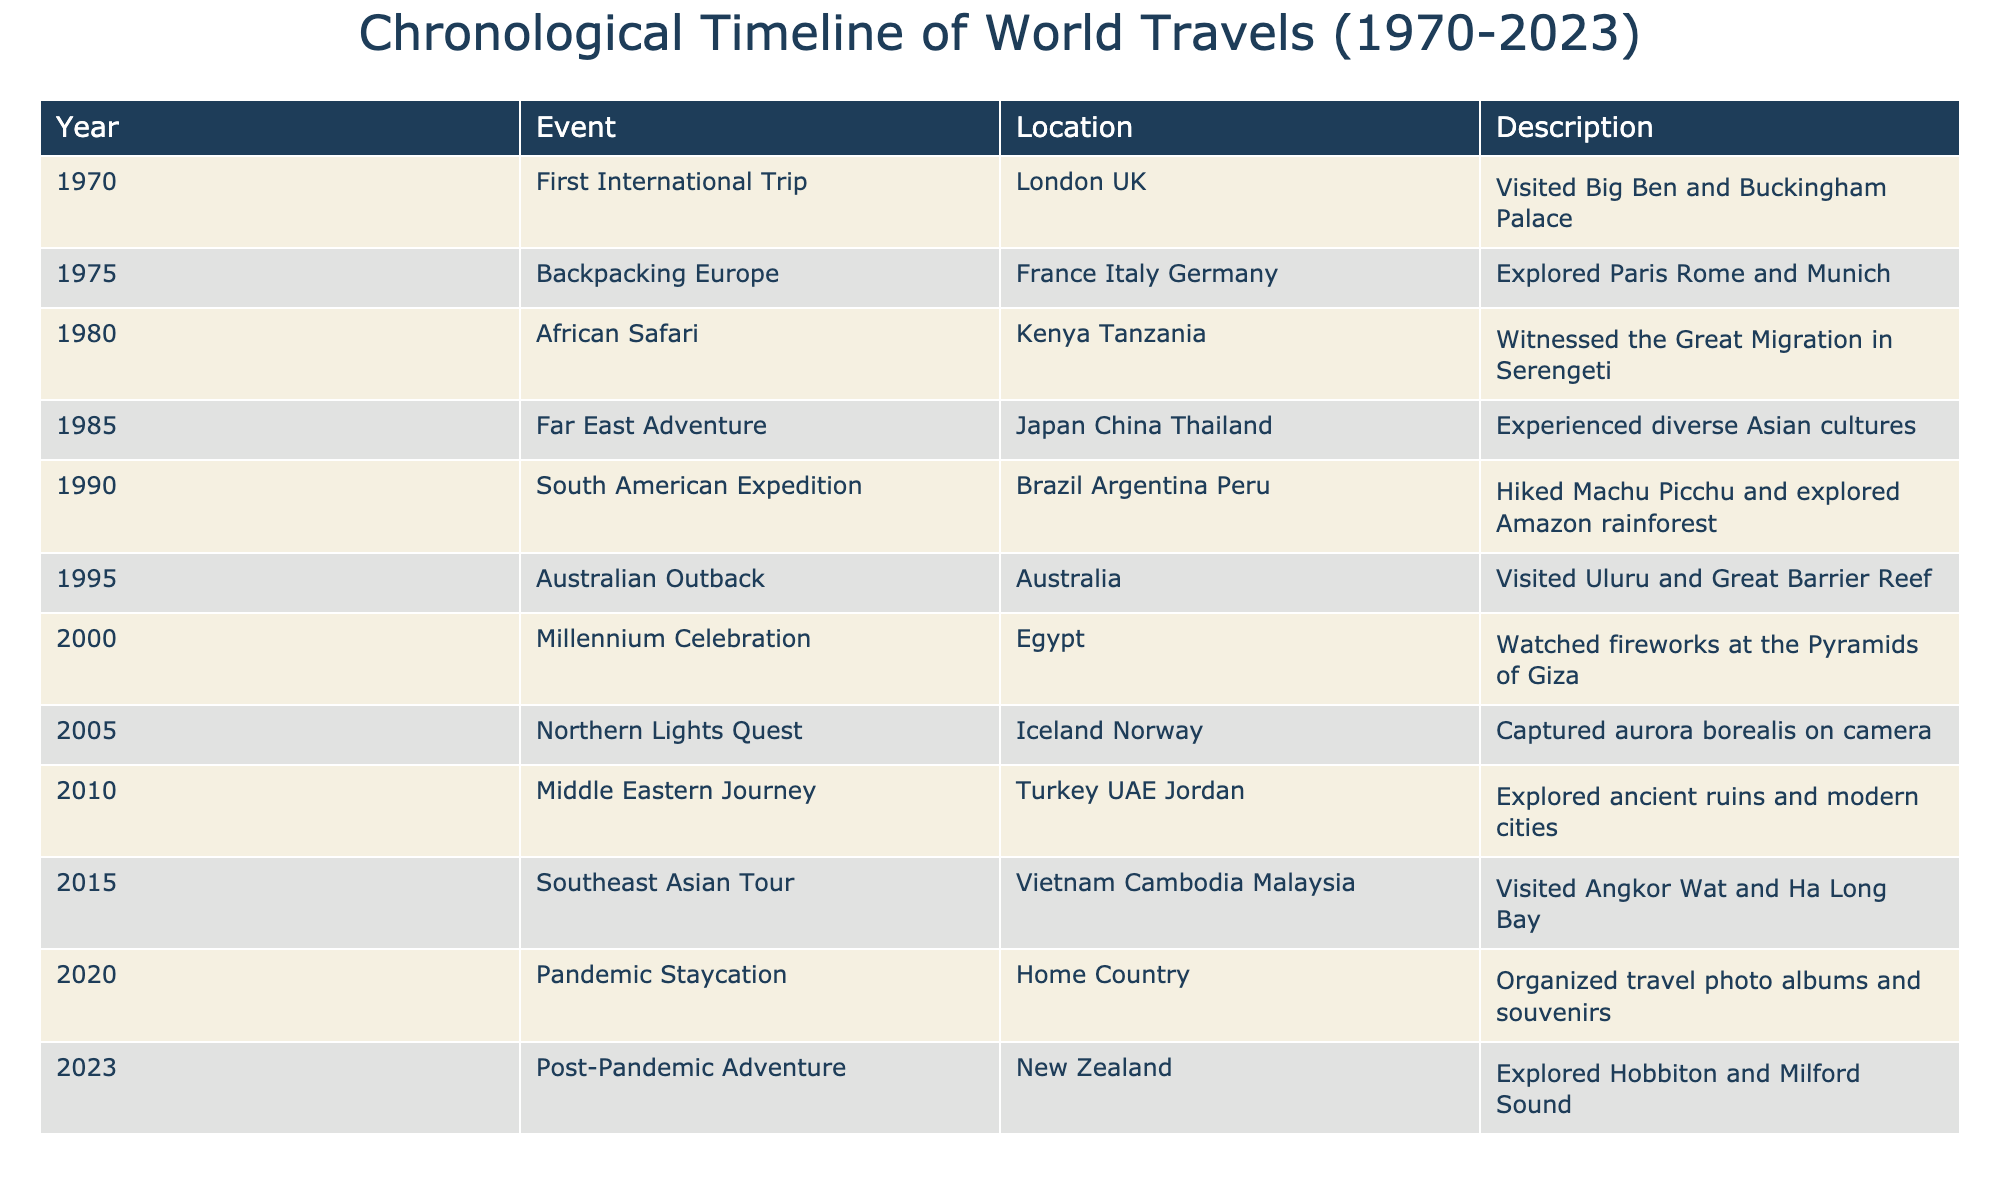What year did the first international trip take place? The first international trip is listed in the table for the year 1970. Therefore, the answer is directly found in the event row.
Answer: 1970 How many different countries were visited during the backpacking trip in Europe? The backpacking trip in Europe mentioned three countries: France, Italy, and Germany. Counting these gives a total of three different countries.
Answer: 3 True or false: An African safari was experienced in the same decade as the first international trip. The first international trip occurred in 1970, and the African safari was in 1980. Both events are in different decades; thus, the statement is false.
Answer: False What was the last recorded travel experience in the timeline? The last recorded travel experience in the timeline occurred in 2023 and is labeled as a "Post-Pandemic Adventure" in New Zealand.
Answer: Post-Pandemic Adventure If we consider only the travel events from the 1990s, how many events occurred, and where did these adventures take place? The table shows two travel events from the 1990s: the South American Expedition in Brazil, Argentina, and Peru (1990), and the Australian Outback in Australia (1995). Therefore, there were two events in the 1990s: one in South America and one in Australia.
Answer: 2 events: South America and Australia What is the range of years in which the travels took place? The travels commenced in 1970 and concluded in 2023. To calculate the range, subtract the start year (1970) from the end year (2023): 2023 - 1970 = 53 years. The range of travel years is thus 53 years.
Answer: 53 years Which continent was visited first based on the timeline? The first event in the timeline occurred in London, UK, which is located in Europe. Therefore, Europe is the continent visited first based on the timeline.
Answer: Europe How many travel experiences involved a natural wonder or natural phenomenon? The table lists events where natural wonders were present: the African safari (Great Migration), Australian Outback (Great Barrier Reef), and Northern Lights Quest (aurora borealis). Summing these gives three experiences involving natural phenomena.
Answer: 3 experiences What type of activities characterized the Southeast Asian tour? The Southeast Asian tour in the table notes visits to Angkor Wat and Ha Long Bay, which indicates it involved cultural exploration (Angkor Wat) and natural sightseeing (Ha Long Bay). This suggests a mix of cultural and natural activities.
Answer: Cultural and natural activities 